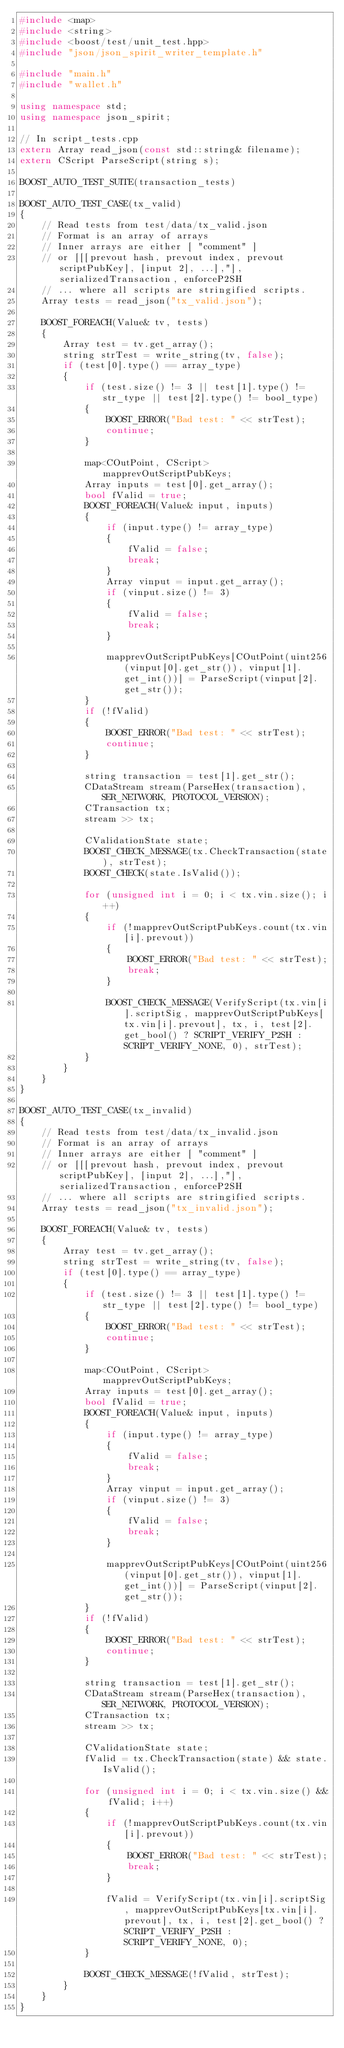Convert code to text. <code><loc_0><loc_0><loc_500><loc_500><_C++_>#include <map>
#include <string>
#include <boost/test/unit_test.hpp>
#include "json/json_spirit_writer_template.h"

#include "main.h"
#include "wallet.h"

using namespace std;
using namespace json_spirit;

// In script_tests.cpp
extern Array read_json(const std::string& filename);
extern CScript ParseScript(string s);

BOOST_AUTO_TEST_SUITE(transaction_tests)

BOOST_AUTO_TEST_CASE(tx_valid)
{
    // Read tests from test/data/tx_valid.json
    // Format is an array of arrays
    // Inner arrays are either [ "comment" ]
    // or [[[prevout hash, prevout index, prevout scriptPubKey], [input 2], ...],"], serializedTransaction, enforceP2SH
    // ... where all scripts are stringified scripts.
    Array tests = read_json("tx_valid.json");

    BOOST_FOREACH(Value& tv, tests)
    {
        Array test = tv.get_array();
        string strTest = write_string(tv, false);
        if (test[0].type() == array_type)
        {
            if (test.size() != 3 || test[1].type() != str_type || test[2].type() != bool_type)
            {
                BOOST_ERROR("Bad test: " << strTest);
                continue;
            }

            map<COutPoint, CScript> mapprevOutScriptPubKeys;
            Array inputs = test[0].get_array();
            bool fValid = true;
            BOOST_FOREACH(Value& input, inputs)
            {
                if (input.type() != array_type)
                {
                    fValid = false;
                    break;
                }
                Array vinput = input.get_array();
                if (vinput.size() != 3)
                {
                    fValid = false;
                    break;
                }

                mapprevOutScriptPubKeys[COutPoint(uint256(vinput[0].get_str()), vinput[1].get_int())] = ParseScript(vinput[2].get_str());
            }
            if (!fValid)
            {
                BOOST_ERROR("Bad test: " << strTest);
                continue;
            }

            string transaction = test[1].get_str();
            CDataStream stream(ParseHex(transaction), SER_NETWORK, PROTOCOL_VERSION);
            CTransaction tx;
            stream >> tx;

            CValidationState state;
            BOOST_CHECK_MESSAGE(tx.CheckTransaction(state), strTest);
            BOOST_CHECK(state.IsValid());

            for (unsigned int i = 0; i < tx.vin.size(); i++)
            {
                if (!mapprevOutScriptPubKeys.count(tx.vin[i].prevout))
                {
                    BOOST_ERROR("Bad test: " << strTest);
                    break;
                }

                BOOST_CHECK_MESSAGE(VerifyScript(tx.vin[i].scriptSig, mapprevOutScriptPubKeys[tx.vin[i].prevout], tx, i, test[2].get_bool() ? SCRIPT_VERIFY_P2SH : SCRIPT_VERIFY_NONE, 0), strTest);
            }
        }
    }
}

BOOST_AUTO_TEST_CASE(tx_invalid)
{
    // Read tests from test/data/tx_invalid.json
    // Format is an array of arrays
    // Inner arrays are either [ "comment" ]
    // or [[[prevout hash, prevout index, prevout scriptPubKey], [input 2], ...],"], serializedTransaction, enforceP2SH
    // ... where all scripts are stringified scripts.
    Array tests = read_json("tx_invalid.json");

    BOOST_FOREACH(Value& tv, tests)
    {
        Array test = tv.get_array();
        string strTest = write_string(tv, false);
        if (test[0].type() == array_type)
        {
            if (test.size() != 3 || test[1].type() != str_type || test[2].type() != bool_type)
            {
                BOOST_ERROR("Bad test: " << strTest);
                continue;
            }

            map<COutPoint, CScript> mapprevOutScriptPubKeys;
            Array inputs = test[0].get_array();
            bool fValid = true;
            BOOST_FOREACH(Value& input, inputs)
            {
                if (input.type() != array_type)
                {
                    fValid = false;
                    break;
                }
                Array vinput = input.get_array();
                if (vinput.size() != 3)
                {
                    fValid = false;
                    break;
                }

                mapprevOutScriptPubKeys[COutPoint(uint256(vinput[0].get_str()), vinput[1].get_int())] = ParseScript(vinput[2].get_str());
            }
            if (!fValid)
            {
                BOOST_ERROR("Bad test: " << strTest);
                continue;
            }

            string transaction = test[1].get_str();
            CDataStream stream(ParseHex(transaction), SER_NETWORK, PROTOCOL_VERSION);
            CTransaction tx;
            stream >> tx;

            CValidationState state;
            fValid = tx.CheckTransaction(state) && state.IsValid();

            for (unsigned int i = 0; i < tx.vin.size() && fValid; i++)
            {
                if (!mapprevOutScriptPubKeys.count(tx.vin[i].prevout))
                {
                    BOOST_ERROR("Bad test: " << strTest);
                    break;
                }

                fValid = VerifyScript(tx.vin[i].scriptSig, mapprevOutScriptPubKeys[tx.vin[i].prevout], tx, i, test[2].get_bool() ? SCRIPT_VERIFY_P2SH : SCRIPT_VERIFY_NONE, 0);
            }

            BOOST_CHECK_MESSAGE(!fValid, strTest);
        }
    }
}
</code> 